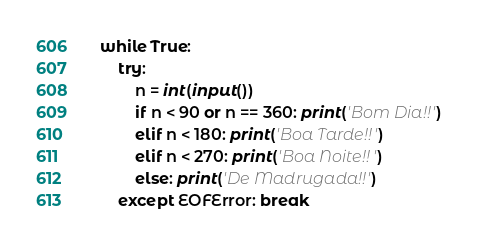<code> <loc_0><loc_0><loc_500><loc_500><_Python_>while True:
    try:
        n = int(input())
        if n < 90 or n == 360: print('Bom Dia!!')
        elif n < 180: print('Boa Tarde!!')
        elif n < 270: print('Boa Noite!!')
        else: print('De Madrugada!!')
    except EOFError: break
</code> 